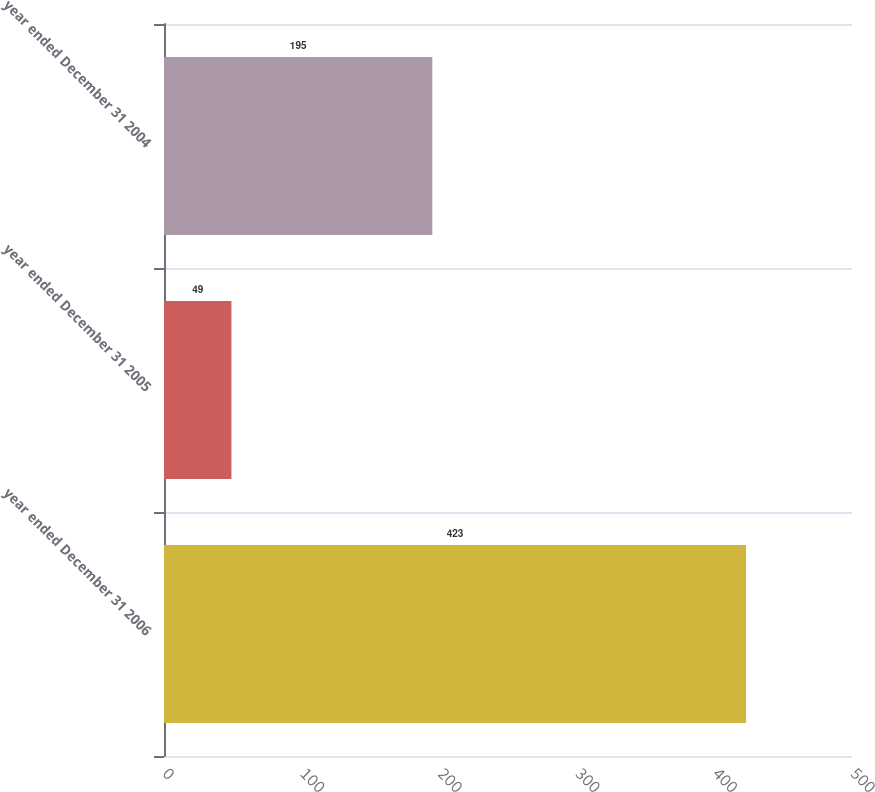Convert chart to OTSL. <chart><loc_0><loc_0><loc_500><loc_500><bar_chart><fcel>year ended December 31 2006<fcel>year ended December 31 2005<fcel>year ended December 31 2004<nl><fcel>423<fcel>49<fcel>195<nl></chart> 